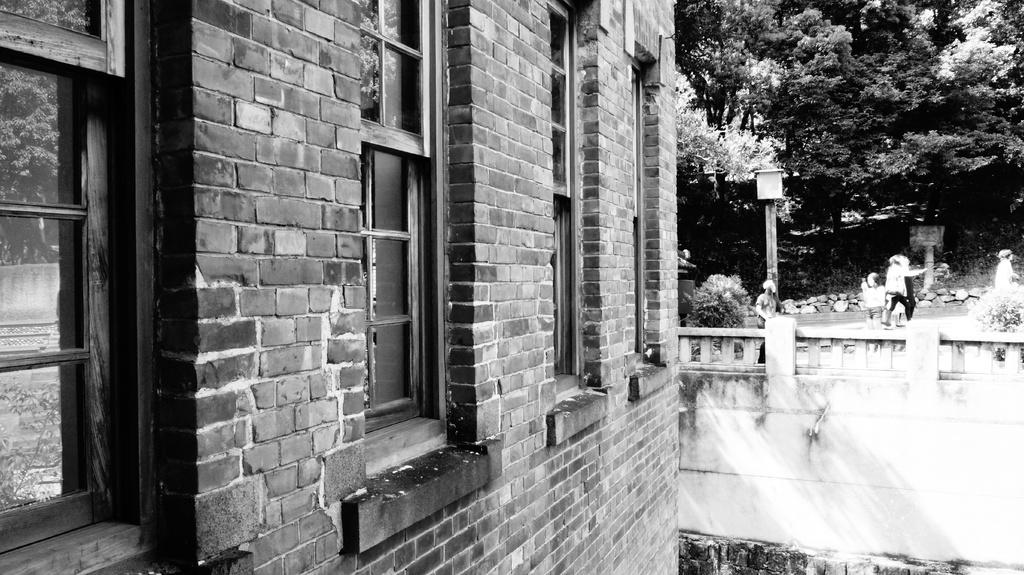Where are the people located in the image? The people are on the ground, on a wall, on a pole, and on stones in the image. What else can be seen in the image besides people? There are plants, a building with windows, and trees visible in the background of the image. Can you describe the building in the image? The building has windows. What type of vegetation is present in the image? There are plants and trees visible in the image. What type of tray is being used by the people on the wall in the image? There is no tray present in the image; the people are on a wall without any visible objects. 